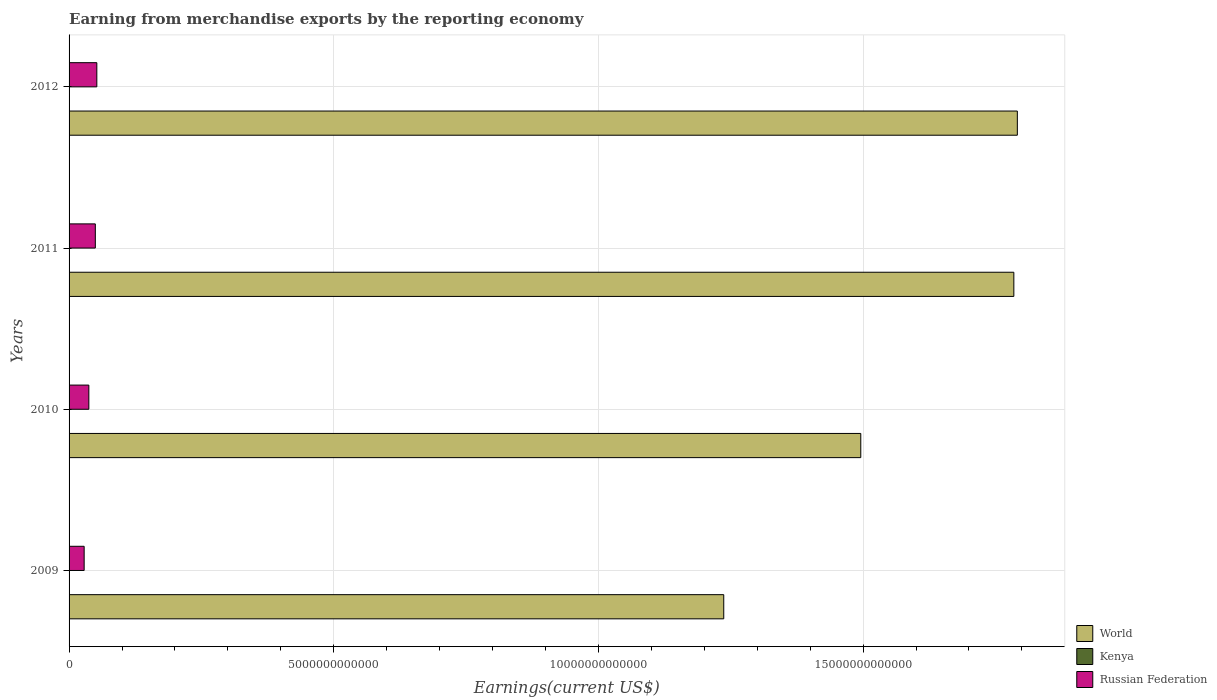How many different coloured bars are there?
Your response must be concise. 3. How many bars are there on the 1st tick from the top?
Make the answer very short. 3. How many bars are there on the 4th tick from the bottom?
Provide a short and direct response. 3. What is the label of the 2nd group of bars from the top?
Keep it short and to the point. 2011. In how many cases, is the number of bars for a given year not equal to the number of legend labels?
Make the answer very short. 0. What is the amount earned from merchandise exports in World in 2009?
Your response must be concise. 1.24e+13. Across all years, what is the maximum amount earned from merchandise exports in World?
Your response must be concise. 1.79e+13. Across all years, what is the minimum amount earned from merchandise exports in World?
Your answer should be compact. 1.24e+13. In which year was the amount earned from merchandise exports in Russian Federation minimum?
Your answer should be very brief. 2009. What is the total amount earned from merchandise exports in World in the graph?
Ensure brevity in your answer.  6.31e+13. What is the difference between the amount earned from merchandise exports in Russian Federation in 2010 and that in 2012?
Offer a very short reply. -1.51e+11. What is the difference between the amount earned from merchandise exports in World in 2009 and the amount earned from merchandise exports in Kenya in 2011?
Provide a succinct answer. 1.24e+13. What is the average amount earned from merchandise exports in Kenya per year?
Provide a succinct answer. 5.18e+09. In the year 2010, what is the difference between the amount earned from merchandise exports in World and amount earned from merchandise exports in Russian Federation?
Give a very brief answer. 1.46e+13. In how many years, is the amount earned from merchandise exports in Russian Federation greater than 1000000000000 US$?
Ensure brevity in your answer.  0. What is the ratio of the amount earned from merchandise exports in World in 2011 to that in 2012?
Provide a succinct answer. 1. Is the amount earned from merchandise exports in World in 2009 less than that in 2011?
Your answer should be very brief. Yes. What is the difference between the highest and the second highest amount earned from merchandise exports in Russian Federation?
Offer a very short reply. 2.86e+1. What is the difference between the highest and the lowest amount earned from merchandise exports in Russian Federation?
Your answer should be compact. 2.39e+11. In how many years, is the amount earned from merchandise exports in World greater than the average amount earned from merchandise exports in World taken over all years?
Keep it short and to the point. 2. What does the 1st bar from the top in 2010 represents?
Give a very brief answer. Russian Federation. What does the 2nd bar from the bottom in 2009 represents?
Make the answer very short. Kenya. Is it the case that in every year, the sum of the amount earned from merchandise exports in Kenya and amount earned from merchandise exports in Russian Federation is greater than the amount earned from merchandise exports in World?
Your response must be concise. No. How many bars are there?
Your response must be concise. 12. Are all the bars in the graph horizontal?
Keep it short and to the point. Yes. How many years are there in the graph?
Provide a succinct answer. 4. What is the difference between two consecutive major ticks on the X-axis?
Provide a succinct answer. 5.00e+12. Are the values on the major ticks of X-axis written in scientific E-notation?
Offer a very short reply. No. Does the graph contain grids?
Give a very brief answer. Yes. Where does the legend appear in the graph?
Provide a short and direct response. Bottom right. How many legend labels are there?
Provide a succinct answer. 3. How are the legend labels stacked?
Make the answer very short. Vertical. What is the title of the graph?
Ensure brevity in your answer.  Earning from merchandise exports by the reporting economy. What is the label or title of the X-axis?
Provide a short and direct response. Earnings(current US$). What is the Earnings(current US$) of World in 2009?
Make the answer very short. 1.24e+13. What is the Earnings(current US$) in Kenya in 2009?
Your answer should be compact. 4.32e+09. What is the Earnings(current US$) in Russian Federation in 2009?
Your answer should be compact. 2.85e+11. What is the Earnings(current US$) in World in 2010?
Give a very brief answer. 1.50e+13. What is the Earnings(current US$) of Kenya in 2010?
Offer a terse response. 4.96e+09. What is the Earnings(current US$) of Russian Federation in 2010?
Keep it short and to the point. 3.74e+11. What is the Earnings(current US$) in World in 2011?
Provide a succinct answer. 1.78e+13. What is the Earnings(current US$) of Kenya in 2011?
Your answer should be compact. 5.67e+09. What is the Earnings(current US$) in Russian Federation in 2011?
Keep it short and to the point. 4.96e+11. What is the Earnings(current US$) of World in 2012?
Give a very brief answer. 1.79e+13. What is the Earnings(current US$) of Kenya in 2012?
Your answer should be very brief. 5.79e+09. What is the Earnings(current US$) of Russian Federation in 2012?
Make the answer very short. 5.24e+11. Across all years, what is the maximum Earnings(current US$) of World?
Your response must be concise. 1.79e+13. Across all years, what is the maximum Earnings(current US$) of Kenya?
Make the answer very short. 5.79e+09. Across all years, what is the maximum Earnings(current US$) of Russian Federation?
Make the answer very short. 5.24e+11. Across all years, what is the minimum Earnings(current US$) of World?
Make the answer very short. 1.24e+13. Across all years, what is the minimum Earnings(current US$) of Kenya?
Provide a short and direct response. 4.32e+09. Across all years, what is the minimum Earnings(current US$) of Russian Federation?
Offer a very short reply. 2.85e+11. What is the total Earnings(current US$) of World in the graph?
Ensure brevity in your answer.  6.31e+13. What is the total Earnings(current US$) of Kenya in the graph?
Make the answer very short. 2.07e+1. What is the total Earnings(current US$) in Russian Federation in the graph?
Your response must be concise. 1.68e+12. What is the difference between the Earnings(current US$) in World in 2009 and that in 2010?
Offer a terse response. -2.59e+12. What is the difference between the Earnings(current US$) in Kenya in 2009 and that in 2010?
Offer a very short reply. -6.46e+08. What is the difference between the Earnings(current US$) in Russian Federation in 2009 and that in 2010?
Your answer should be compact. -8.87e+1. What is the difference between the Earnings(current US$) of World in 2009 and that in 2011?
Provide a short and direct response. -5.48e+12. What is the difference between the Earnings(current US$) in Kenya in 2009 and that in 2011?
Your answer should be compact. -1.35e+09. What is the difference between the Earnings(current US$) in Russian Federation in 2009 and that in 2011?
Offer a terse response. -2.11e+11. What is the difference between the Earnings(current US$) in World in 2009 and that in 2012?
Your response must be concise. -5.55e+12. What is the difference between the Earnings(current US$) in Kenya in 2009 and that in 2012?
Make the answer very short. -1.48e+09. What is the difference between the Earnings(current US$) in Russian Federation in 2009 and that in 2012?
Your answer should be very brief. -2.39e+11. What is the difference between the Earnings(current US$) in World in 2010 and that in 2011?
Your response must be concise. -2.89e+12. What is the difference between the Earnings(current US$) of Kenya in 2010 and that in 2011?
Offer a terse response. -7.06e+08. What is the difference between the Earnings(current US$) in Russian Federation in 2010 and that in 2011?
Provide a succinct answer. -1.22e+11. What is the difference between the Earnings(current US$) of World in 2010 and that in 2012?
Offer a terse response. -2.96e+12. What is the difference between the Earnings(current US$) in Kenya in 2010 and that in 2012?
Your response must be concise. -8.33e+08. What is the difference between the Earnings(current US$) in Russian Federation in 2010 and that in 2012?
Provide a short and direct response. -1.51e+11. What is the difference between the Earnings(current US$) of World in 2011 and that in 2012?
Offer a very short reply. -6.61e+1. What is the difference between the Earnings(current US$) of Kenya in 2011 and that in 2012?
Offer a very short reply. -1.27e+08. What is the difference between the Earnings(current US$) of Russian Federation in 2011 and that in 2012?
Give a very brief answer. -2.86e+1. What is the difference between the Earnings(current US$) of World in 2009 and the Earnings(current US$) of Kenya in 2010?
Your answer should be very brief. 1.24e+13. What is the difference between the Earnings(current US$) in World in 2009 and the Earnings(current US$) in Russian Federation in 2010?
Give a very brief answer. 1.20e+13. What is the difference between the Earnings(current US$) in Kenya in 2009 and the Earnings(current US$) in Russian Federation in 2010?
Ensure brevity in your answer.  -3.69e+11. What is the difference between the Earnings(current US$) in World in 2009 and the Earnings(current US$) in Kenya in 2011?
Your answer should be compact. 1.24e+13. What is the difference between the Earnings(current US$) of World in 2009 and the Earnings(current US$) of Russian Federation in 2011?
Your response must be concise. 1.19e+13. What is the difference between the Earnings(current US$) in Kenya in 2009 and the Earnings(current US$) in Russian Federation in 2011?
Your response must be concise. -4.92e+11. What is the difference between the Earnings(current US$) of World in 2009 and the Earnings(current US$) of Kenya in 2012?
Your response must be concise. 1.24e+13. What is the difference between the Earnings(current US$) of World in 2009 and the Earnings(current US$) of Russian Federation in 2012?
Ensure brevity in your answer.  1.18e+13. What is the difference between the Earnings(current US$) of Kenya in 2009 and the Earnings(current US$) of Russian Federation in 2012?
Provide a succinct answer. -5.20e+11. What is the difference between the Earnings(current US$) in World in 2010 and the Earnings(current US$) in Kenya in 2011?
Ensure brevity in your answer.  1.50e+13. What is the difference between the Earnings(current US$) in World in 2010 and the Earnings(current US$) in Russian Federation in 2011?
Offer a very short reply. 1.45e+13. What is the difference between the Earnings(current US$) in Kenya in 2010 and the Earnings(current US$) in Russian Federation in 2011?
Keep it short and to the point. -4.91e+11. What is the difference between the Earnings(current US$) in World in 2010 and the Earnings(current US$) in Kenya in 2012?
Offer a terse response. 1.50e+13. What is the difference between the Earnings(current US$) in World in 2010 and the Earnings(current US$) in Russian Federation in 2012?
Your answer should be compact. 1.44e+13. What is the difference between the Earnings(current US$) in Kenya in 2010 and the Earnings(current US$) in Russian Federation in 2012?
Give a very brief answer. -5.20e+11. What is the difference between the Earnings(current US$) in World in 2011 and the Earnings(current US$) in Kenya in 2012?
Make the answer very short. 1.78e+13. What is the difference between the Earnings(current US$) of World in 2011 and the Earnings(current US$) of Russian Federation in 2012?
Offer a very short reply. 1.73e+13. What is the difference between the Earnings(current US$) of Kenya in 2011 and the Earnings(current US$) of Russian Federation in 2012?
Give a very brief answer. -5.19e+11. What is the average Earnings(current US$) in World per year?
Your response must be concise. 1.58e+13. What is the average Earnings(current US$) in Kenya per year?
Your answer should be very brief. 5.18e+09. What is the average Earnings(current US$) in Russian Federation per year?
Ensure brevity in your answer.  4.20e+11. In the year 2009, what is the difference between the Earnings(current US$) in World and Earnings(current US$) in Kenya?
Make the answer very short. 1.24e+13. In the year 2009, what is the difference between the Earnings(current US$) in World and Earnings(current US$) in Russian Federation?
Your answer should be very brief. 1.21e+13. In the year 2009, what is the difference between the Earnings(current US$) of Kenya and Earnings(current US$) of Russian Federation?
Keep it short and to the point. -2.81e+11. In the year 2010, what is the difference between the Earnings(current US$) of World and Earnings(current US$) of Kenya?
Your answer should be compact. 1.50e+13. In the year 2010, what is the difference between the Earnings(current US$) in World and Earnings(current US$) in Russian Federation?
Your answer should be compact. 1.46e+13. In the year 2010, what is the difference between the Earnings(current US$) in Kenya and Earnings(current US$) in Russian Federation?
Offer a very short reply. -3.69e+11. In the year 2011, what is the difference between the Earnings(current US$) in World and Earnings(current US$) in Kenya?
Your answer should be very brief. 1.78e+13. In the year 2011, what is the difference between the Earnings(current US$) of World and Earnings(current US$) of Russian Federation?
Make the answer very short. 1.74e+13. In the year 2011, what is the difference between the Earnings(current US$) in Kenya and Earnings(current US$) in Russian Federation?
Provide a succinct answer. -4.90e+11. In the year 2012, what is the difference between the Earnings(current US$) of World and Earnings(current US$) of Kenya?
Offer a terse response. 1.79e+13. In the year 2012, what is the difference between the Earnings(current US$) of World and Earnings(current US$) of Russian Federation?
Your response must be concise. 1.74e+13. In the year 2012, what is the difference between the Earnings(current US$) of Kenya and Earnings(current US$) of Russian Federation?
Your response must be concise. -5.19e+11. What is the ratio of the Earnings(current US$) of World in 2009 to that in 2010?
Keep it short and to the point. 0.83. What is the ratio of the Earnings(current US$) of Kenya in 2009 to that in 2010?
Provide a succinct answer. 0.87. What is the ratio of the Earnings(current US$) of Russian Federation in 2009 to that in 2010?
Your answer should be very brief. 0.76. What is the ratio of the Earnings(current US$) in World in 2009 to that in 2011?
Your response must be concise. 0.69. What is the ratio of the Earnings(current US$) in Kenya in 2009 to that in 2011?
Keep it short and to the point. 0.76. What is the ratio of the Earnings(current US$) of Russian Federation in 2009 to that in 2011?
Offer a terse response. 0.57. What is the ratio of the Earnings(current US$) in World in 2009 to that in 2012?
Offer a terse response. 0.69. What is the ratio of the Earnings(current US$) in Kenya in 2009 to that in 2012?
Keep it short and to the point. 0.74. What is the ratio of the Earnings(current US$) of Russian Federation in 2009 to that in 2012?
Ensure brevity in your answer.  0.54. What is the ratio of the Earnings(current US$) in World in 2010 to that in 2011?
Offer a very short reply. 0.84. What is the ratio of the Earnings(current US$) of Kenya in 2010 to that in 2011?
Give a very brief answer. 0.88. What is the ratio of the Earnings(current US$) in Russian Federation in 2010 to that in 2011?
Your response must be concise. 0.75. What is the ratio of the Earnings(current US$) of World in 2010 to that in 2012?
Your answer should be compact. 0.83. What is the ratio of the Earnings(current US$) of Kenya in 2010 to that in 2012?
Offer a terse response. 0.86. What is the ratio of the Earnings(current US$) in Russian Federation in 2010 to that in 2012?
Provide a succinct answer. 0.71. What is the ratio of the Earnings(current US$) in Kenya in 2011 to that in 2012?
Your answer should be compact. 0.98. What is the ratio of the Earnings(current US$) of Russian Federation in 2011 to that in 2012?
Provide a succinct answer. 0.95. What is the difference between the highest and the second highest Earnings(current US$) of World?
Offer a very short reply. 6.61e+1. What is the difference between the highest and the second highest Earnings(current US$) of Kenya?
Ensure brevity in your answer.  1.27e+08. What is the difference between the highest and the second highest Earnings(current US$) in Russian Federation?
Your answer should be very brief. 2.86e+1. What is the difference between the highest and the lowest Earnings(current US$) of World?
Provide a succinct answer. 5.55e+12. What is the difference between the highest and the lowest Earnings(current US$) of Kenya?
Your response must be concise. 1.48e+09. What is the difference between the highest and the lowest Earnings(current US$) of Russian Federation?
Provide a succinct answer. 2.39e+11. 